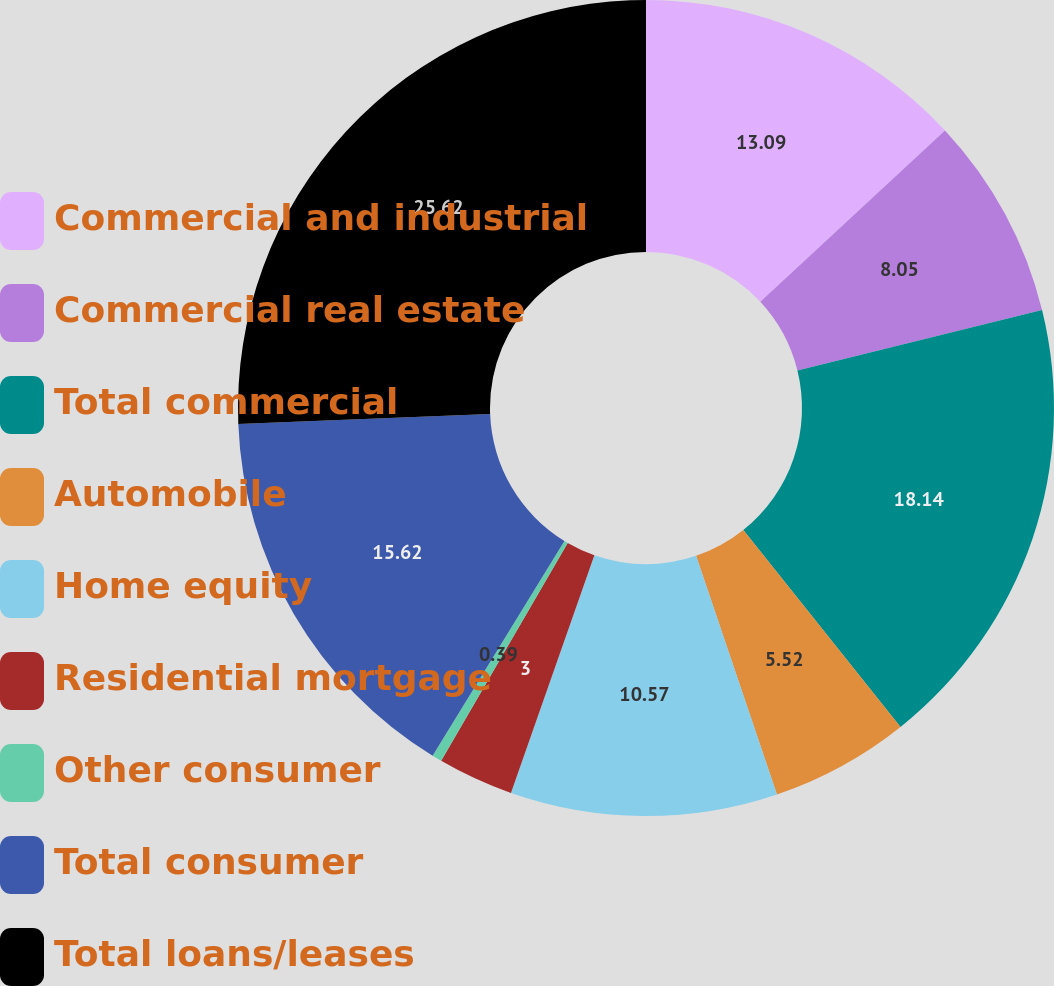Convert chart. <chart><loc_0><loc_0><loc_500><loc_500><pie_chart><fcel>Commercial and industrial<fcel>Commercial real estate<fcel>Total commercial<fcel>Automobile<fcel>Home equity<fcel>Residential mortgage<fcel>Other consumer<fcel>Total consumer<fcel>Total loans/leases<nl><fcel>13.09%<fcel>8.05%<fcel>18.14%<fcel>5.52%<fcel>10.57%<fcel>3.0%<fcel>0.39%<fcel>15.62%<fcel>25.62%<nl></chart> 